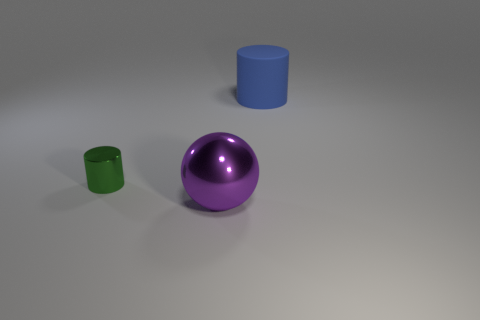Is there anything else that has the same size as the purple shiny ball?
Give a very brief answer. Yes. There is a shiny object that is right of the green metallic cylinder; what color is it?
Give a very brief answer. Purple. What is the object that is left of the big thing on the left side of the object that is on the right side of the purple metal ball made of?
Provide a succinct answer. Metal. There is a metal object that is on the right side of the cylinder in front of the big cylinder; what is its size?
Ensure brevity in your answer.  Large. There is another rubber object that is the same shape as the tiny thing; what color is it?
Offer a terse response. Blue. How many matte objects have the same color as the metallic cylinder?
Offer a very short reply. 0. Is the size of the green cylinder the same as the blue thing?
Provide a short and direct response. No. What material is the small green cylinder?
Give a very brief answer. Metal. The big thing that is the same material as the small cylinder is what color?
Give a very brief answer. Purple. Do the small green cylinder and the large object in front of the tiny metal thing have the same material?
Make the answer very short. Yes. 